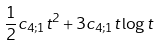Convert formula to latex. <formula><loc_0><loc_0><loc_500><loc_500>\frac { 1 } { 2 } c _ { 4 ; 1 } t ^ { 2 } + 3 c _ { 4 ; 1 } t \log t</formula> 